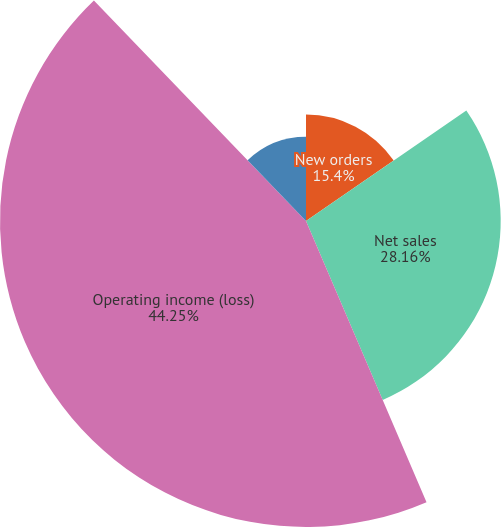<chart> <loc_0><loc_0><loc_500><loc_500><pie_chart><fcel>New orders<fcel>Net sales<fcel>Operating income (loss)<fcel>Non-GAAP adjusted operating<nl><fcel>15.4%<fcel>28.16%<fcel>44.26%<fcel>12.19%<nl></chart> 